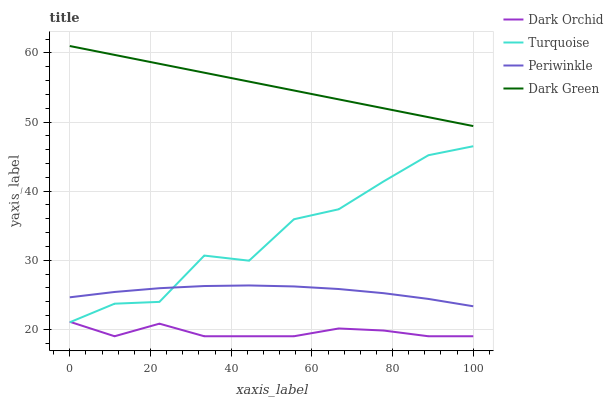Does Dark Orchid have the minimum area under the curve?
Answer yes or no. Yes. Does Dark Green have the maximum area under the curve?
Answer yes or no. Yes. Does Periwinkle have the minimum area under the curve?
Answer yes or no. No. Does Periwinkle have the maximum area under the curve?
Answer yes or no. No. Is Dark Green the smoothest?
Answer yes or no. Yes. Is Turquoise the roughest?
Answer yes or no. Yes. Is Periwinkle the smoothest?
Answer yes or no. No. Is Periwinkle the roughest?
Answer yes or no. No. Does Periwinkle have the lowest value?
Answer yes or no. No. Does Dark Green have the highest value?
Answer yes or no. Yes. Does Periwinkle have the highest value?
Answer yes or no. No. Is Dark Orchid less than Dark Green?
Answer yes or no. Yes. Is Periwinkle greater than Dark Orchid?
Answer yes or no. Yes. Does Turquoise intersect Dark Orchid?
Answer yes or no. Yes. Is Turquoise less than Dark Orchid?
Answer yes or no. No. Is Turquoise greater than Dark Orchid?
Answer yes or no. No. Does Dark Orchid intersect Dark Green?
Answer yes or no. No. 